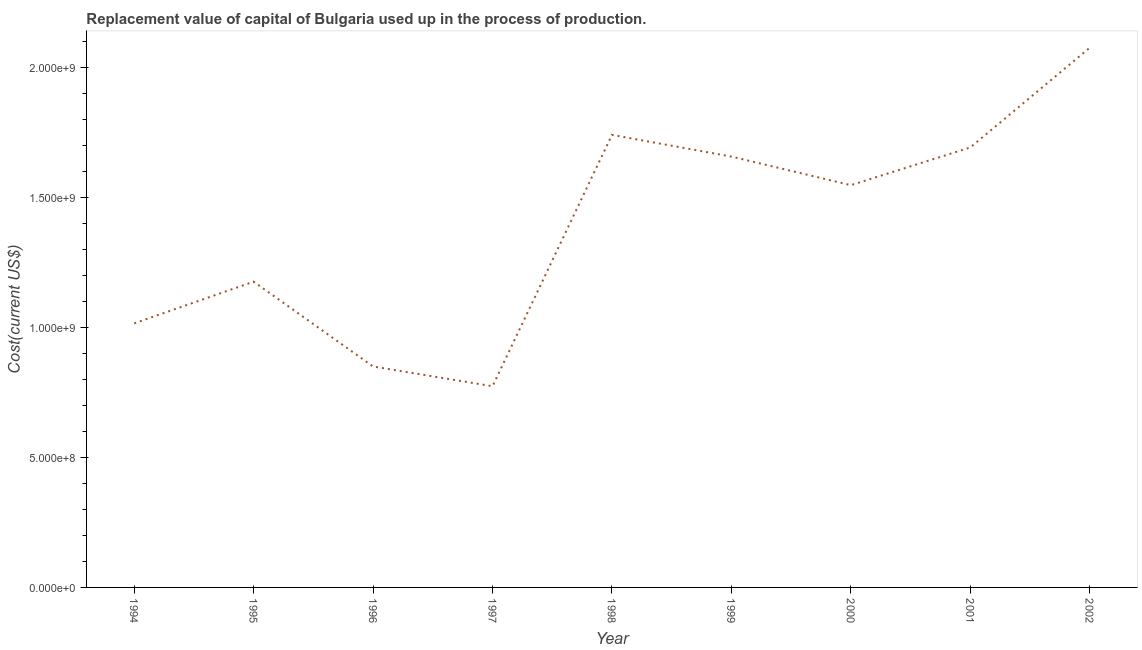What is the consumption of fixed capital in 2000?
Make the answer very short. 1.55e+09. Across all years, what is the maximum consumption of fixed capital?
Your response must be concise. 2.08e+09. Across all years, what is the minimum consumption of fixed capital?
Provide a succinct answer. 7.74e+08. What is the sum of the consumption of fixed capital?
Your answer should be very brief. 1.25e+1. What is the difference between the consumption of fixed capital in 1999 and 2000?
Give a very brief answer. 1.10e+08. What is the average consumption of fixed capital per year?
Ensure brevity in your answer.  1.39e+09. What is the median consumption of fixed capital?
Your answer should be very brief. 1.55e+09. In how many years, is the consumption of fixed capital greater than 200000000 US$?
Ensure brevity in your answer.  9. What is the ratio of the consumption of fixed capital in 1996 to that in 1999?
Provide a short and direct response. 0.51. Is the consumption of fixed capital in 1996 less than that in 2002?
Make the answer very short. Yes. Is the difference between the consumption of fixed capital in 1996 and 2002 greater than the difference between any two years?
Your answer should be very brief. No. What is the difference between the highest and the second highest consumption of fixed capital?
Keep it short and to the point. 3.35e+08. Is the sum of the consumption of fixed capital in 1997 and 2002 greater than the maximum consumption of fixed capital across all years?
Ensure brevity in your answer.  Yes. What is the difference between the highest and the lowest consumption of fixed capital?
Keep it short and to the point. 1.30e+09. In how many years, is the consumption of fixed capital greater than the average consumption of fixed capital taken over all years?
Ensure brevity in your answer.  5. How many lines are there?
Offer a terse response. 1. How many years are there in the graph?
Make the answer very short. 9. Does the graph contain any zero values?
Keep it short and to the point. No. What is the title of the graph?
Your response must be concise. Replacement value of capital of Bulgaria used up in the process of production. What is the label or title of the X-axis?
Keep it short and to the point. Year. What is the label or title of the Y-axis?
Your answer should be very brief. Cost(current US$). What is the Cost(current US$) in 1994?
Offer a very short reply. 1.02e+09. What is the Cost(current US$) in 1995?
Your answer should be compact. 1.18e+09. What is the Cost(current US$) of 1996?
Make the answer very short. 8.50e+08. What is the Cost(current US$) in 1997?
Offer a very short reply. 7.74e+08. What is the Cost(current US$) of 1998?
Offer a terse response. 1.74e+09. What is the Cost(current US$) of 1999?
Your answer should be very brief. 1.66e+09. What is the Cost(current US$) of 2000?
Provide a succinct answer. 1.55e+09. What is the Cost(current US$) of 2001?
Make the answer very short. 1.69e+09. What is the Cost(current US$) in 2002?
Offer a very short reply. 2.08e+09. What is the difference between the Cost(current US$) in 1994 and 1995?
Your response must be concise. -1.60e+08. What is the difference between the Cost(current US$) in 1994 and 1996?
Offer a terse response. 1.66e+08. What is the difference between the Cost(current US$) in 1994 and 1997?
Offer a terse response. 2.42e+08. What is the difference between the Cost(current US$) in 1994 and 1998?
Provide a short and direct response. -7.25e+08. What is the difference between the Cost(current US$) in 1994 and 1999?
Offer a very short reply. -6.42e+08. What is the difference between the Cost(current US$) in 1994 and 2000?
Provide a short and direct response. -5.32e+08. What is the difference between the Cost(current US$) in 1994 and 2001?
Keep it short and to the point. -6.77e+08. What is the difference between the Cost(current US$) in 1994 and 2002?
Your response must be concise. -1.06e+09. What is the difference between the Cost(current US$) in 1995 and 1996?
Keep it short and to the point. 3.26e+08. What is the difference between the Cost(current US$) in 1995 and 1997?
Your answer should be compact. 4.02e+08. What is the difference between the Cost(current US$) in 1995 and 1998?
Ensure brevity in your answer.  -5.65e+08. What is the difference between the Cost(current US$) in 1995 and 1999?
Ensure brevity in your answer.  -4.81e+08. What is the difference between the Cost(current US$) in 1995 and 2000?
Your answer should be very brief. -3.71e+08. What is the difference between the Cost(current US$) in 1995 and 2001?
Your answer should be very brief. -5.17e+08. What is the difference between the Cost(current US$) in 1995 and 2002?
Your answer should be very brief. -9.00e+08. What is the difference between the Cost(current US$) in 1996 and 1997?
Your response must be concise. 7.60e+07. What is the difference between the Cost(current US$) in 1996 and 1998?
Give a very brief answer. -8.91e+08. What is the difference between the Cost(current US$) in 1996 and 1999?
Keep it short and to the point. -8.08e+08. What is the difference between the Cost(current US$) in 1996 and 2000?
Give a very brief answer. -6.98e+08. What is the difference between the Cost(current US$) in 1996 and 2001?
Your answer should be very brief. -8.43e+08. What is the difference between the Cost(current US$) in 1996 and 2002?
Your response must be concise. -1.23e+09. What is the difference between the Cost(current US$) in 1997 and 1998?
Provide a short and direct response. -9.67e+08. What is the difference between the Cost(current US$) in 1997 and 1999?
Make the answer very short. -8.84e+08. What is the difference between the Cost(current US$) in 1997 and 2000?
Keep it short and to the point. -7.74e+08. What is the difference between the Cost(current US$) in 1997 and 2001?
Your response must be concise. -9.19e+08. What is the difference between the Cost(current US$) in 1997 and 2002?
Give a very brief answer. -1.30e+09. What is the difference between the Cost(current US$) in 1998 and 1999?
Your answer should be compact. 8.35e+07. What is the difference between the Cost(current US$) in 1998 and 2000?
Your answer should be compact. 1.93e+08. What is the difference between the Cost(current US$) in 1998 and 2001?
Provide a short and direct response. 4.84e+07. What is the difference between the Cost(current US$) in 1998 and 2002?
Your response must be concise. -3.35e+08. What is the difference between the Cost(current US$) in 1999 and 2000?
Your answer should be very brief. 1.10e+08. What is the difference between the Cost(current US$) in 1999 and 2001?
Offer a very short reply. -3.51e+07. What is the difference between the Cost(current US$) in 1999 and 2002?
Your answer should be compact. -4.19e+08. What is the difference between the Cost(current US$) in 2000 and 2001?
Ensure brevity in your answer.  -1.45e+08. What is the difference between the Cost(current US$) in 2000 and 2002?
Ensure brevity in your answer.  -5.29e+08. What is the difference between the Cost(current US$) in 2001 and 2002?
Offer a very short reply. -3.84e+08. What is the ratio of the Cost(current US$) in 1994 to that in 1995?
Offer a terse response. 0.86. What is the ratio of the Cost(current US$) in 1994 to that in 1996?
Your answer should be very brief. 1.2. What is the ratio of the Cost(current US$) in 1994 to that in 1997?
Your response must be concise. 1.31. What is the ratio of the Cost(current US$) in 1994 to that in 1998?
Offer a terse response. 0.58. What is the ratio of the Cost(current US$) in 1994 to that in 1999?
Provide a short and direct response. 0.61. What is the ratio of the Cost(current US$) in 1994 to that in 2000?
Your response must be concise. 0.66. What is the ratio of the Cost(current US$) in 1994 to that in 2002?
Ensure brevity in your answer.  0.49. What is the ratio of the Cost(current US$) in 1995 to that in 1996?
Make the answer very short. 1.38. What is the ratio of the Cost(current US$) in 1995 to that in 1997?
Your answer should be compact. 1.52. What is the ratio of the Cost(current US$) in 1995 to that in 1998?
Ensure brevity in your answer.  0.68. What is the ratio of the Cost(current US$) in 1995 to that in 1999?
Ensure brevity in your answer.  0.71. What is the ratio of the Cost(current US$) in 1995 to that in 2000?
Your answer should be very brief. 0.76. What is the ratio of the Cost(current US$) in 1995 to that in 2001?
Provide a succinct answer. 0.69. What is the ratio of the Cost(current US$) in 1995 to that in 2002?
Keep it short and to the point. 0.57. What is the ratio of the Cost(current US$) in 1996 to that in 1997?
Keep it short and to the point. 1.1. What is the ratio of the Cost(current US$) in 1996 to that in 1998?
Your answer should be very brief. 0.49. What is the ratio of the Cost(current US$) in 1996 to that in 1999?
Provide a succinct answer. 0.51. What is the ratio of the Cost(current US$) in 1996 to that in 2000?
Offer a terse response. 0.55. What is the ratio of the Cost(current US$) in 1996 to that in 2001?
Your answer should be very brief. 0.5. What is the ratio of the Cost(current US$) in 1996 to that in 2002?
Provide a succinct answer. 0.41. What is the ratio of the Cost(current US$) in 1997 to that in 1998?
Your response must be concise. 0.45. What is the ratio of the Cost(current US$) in 1997 to that in 1999?
Keep it short and to the point. 0.47. What is the ratio of the Cost(current US$) in 1997 to that in 2001?
Offer a very short reply. 0.46. What is the ratio of the Cost(current US$) in 1997 to that in 2002?
Ensure brevity in your answer.  0.37. What is the ratio of the Cost(current US$) in 1998 to that in 2000?
Your response must be concise. 1.12. What is the ratio of the Cost(current US$) in 1998 to that in 2001?
Ensure brevity in your answer.  1.03. What is the ratio of the Cost(current US$) in 1998 to that in 2002?
Offer a terse response. 0.84. What is the ratio of the Cost(current US$) in 1999 to that in 2000?
Give a very brief answer. 1.07. What is the ratio of the Cost(current US$) in 1999 to that in 2002?
Make the answer very short. 0.8. What is the ratio of the Cost(current US$) in 2000 to that in 2001?
Your answer should be very brief. 0.91. What is the ratio of the Cost(current US$) in 2000 to that in 2002?
Keep it short and to the point. 0.74. What is the ratio of the Cost(current US$) in 2001 to that in 2002?
Offer a terse response. 0.81. 